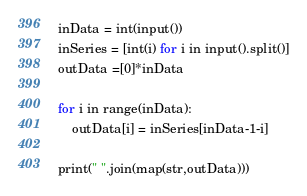<code> <loc_0><loc_0><loc_500><loc_500><_Python_>inData = int(input())
inSeries = [int(i) for i in input().split()]
outData =[0]*inData

for i in range(inData):
    outData[i] = inSeries[inData-1-i]

print(" ".join(map(str,outData)))
</code> 